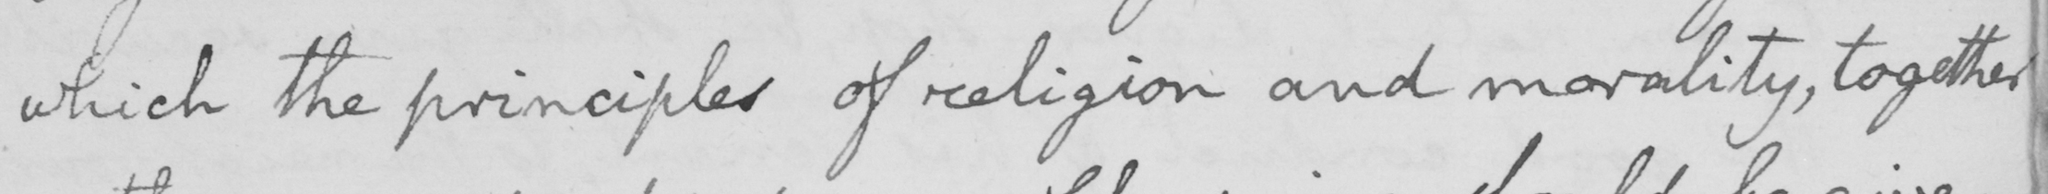Can you read and transcribe this handwriting? which the principles of religion and morality , together 